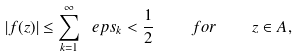Convert formula to latex. <formula><loc_0><loc_0><loc_500><loc_500>| f ( z ) | \leq \sum _ { k = 1 } ^ { \infty } \ e p s _ { k } < \frac { 1 } { 2 } \quad f o r \quad z \in A ,</formula> 